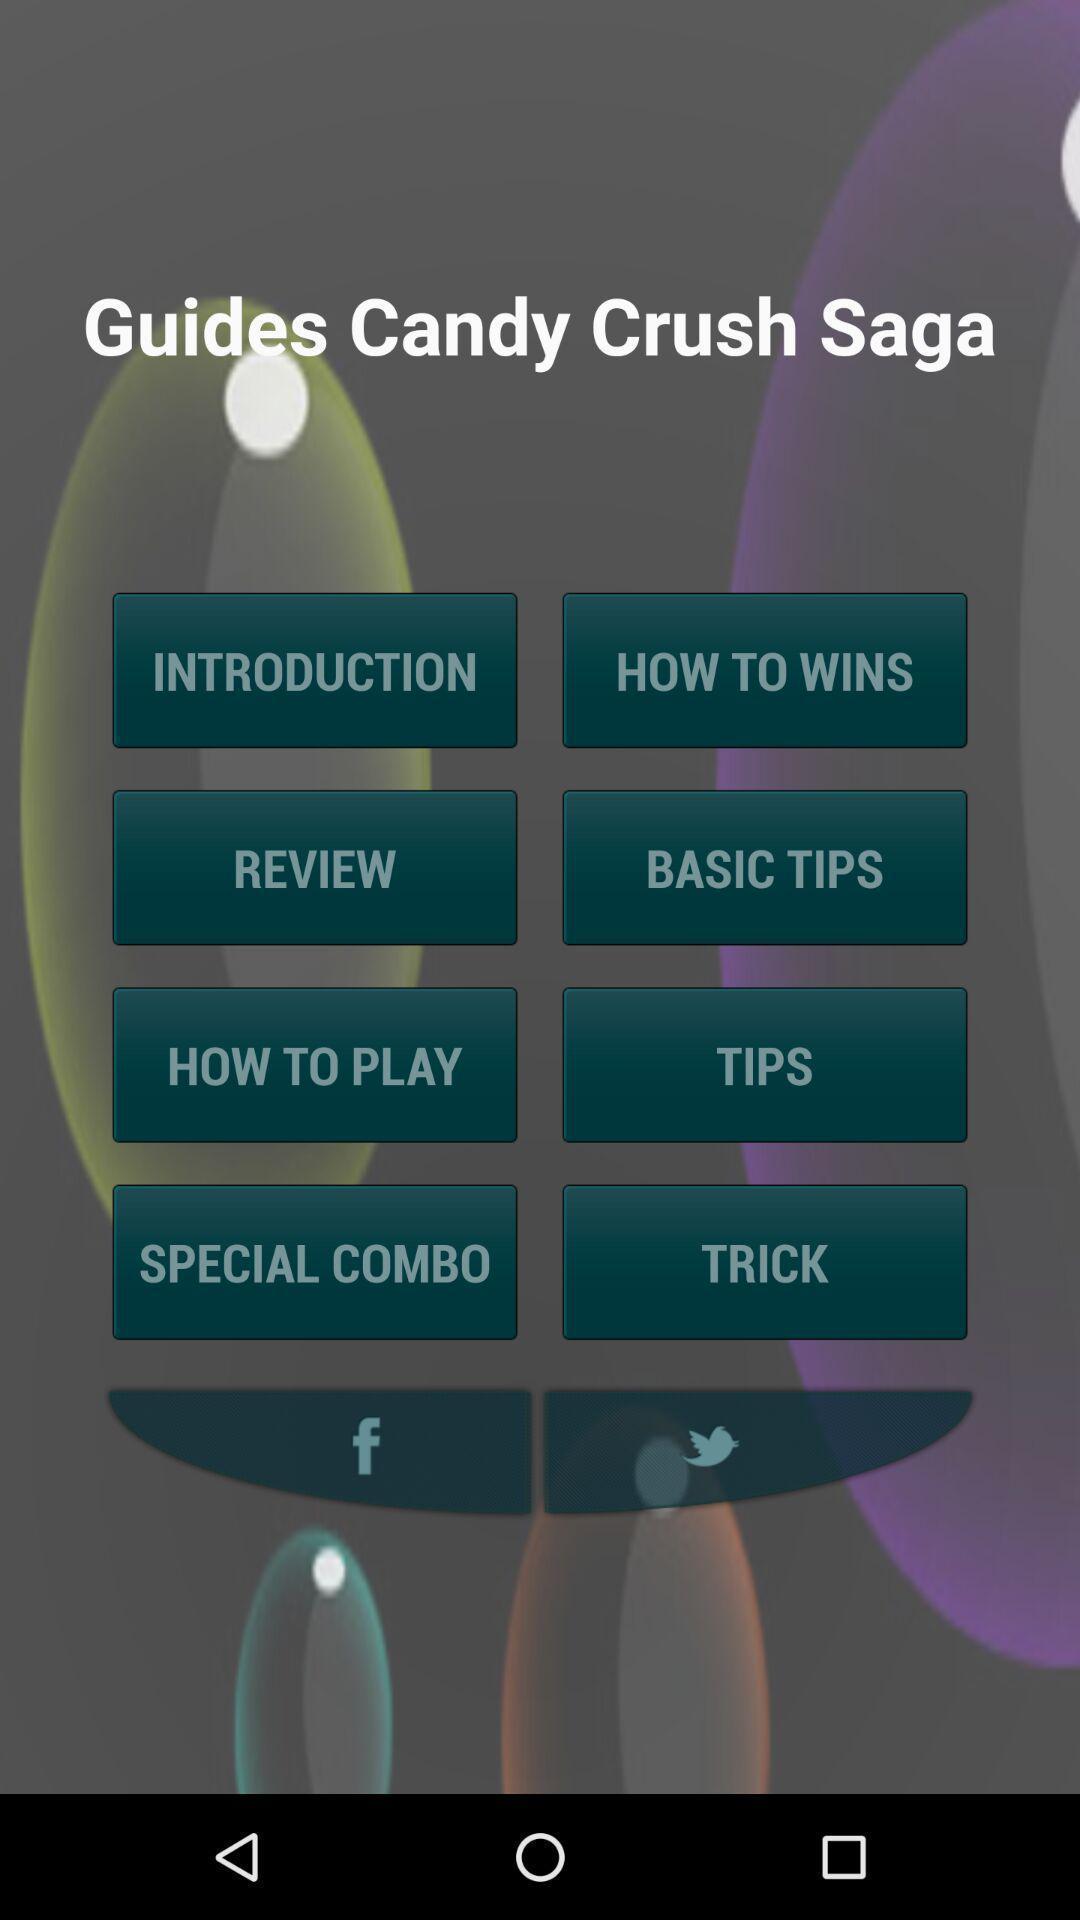Summarize the main components in this picture. Welcome page of a gaming app. 